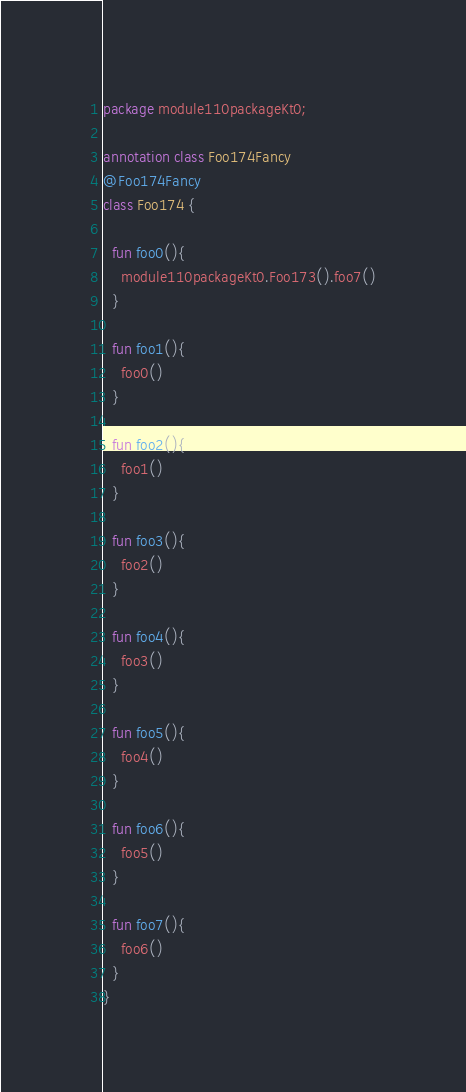Convert code to text. <code><loc_0><loc_0><loc_500><loc_500><_Kotlin_>package module110packageKt0;

annotation class Foo174Fancy
@Foo174Fancy
class Foo174 {

  fun foo0(){
    module110packageKt0.Foo173().foo7()
  }

  fun foo1(){
    foo0()
  }

  fun foo2(){
    foo1()
  }

  fun foo3(){
    foo2()
  }

  fun foo4(){
    foo3()
  }

  fun foo5(){
    foo4()
  }

  fun foo6(){
    foo5()
  }

  fun foo7(){
    foo6()
  }
}</code> 